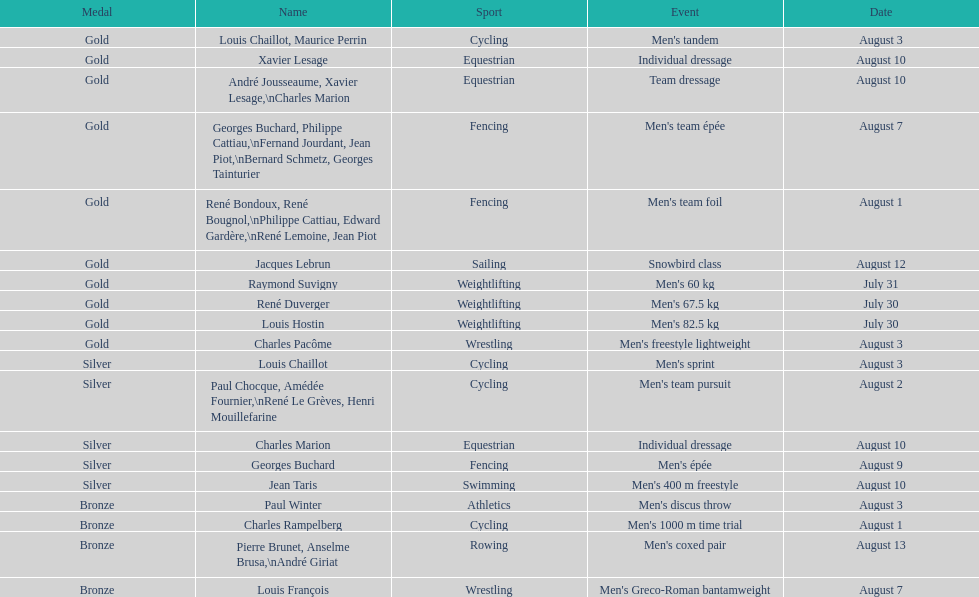Which event won the most medals? Cycling. 